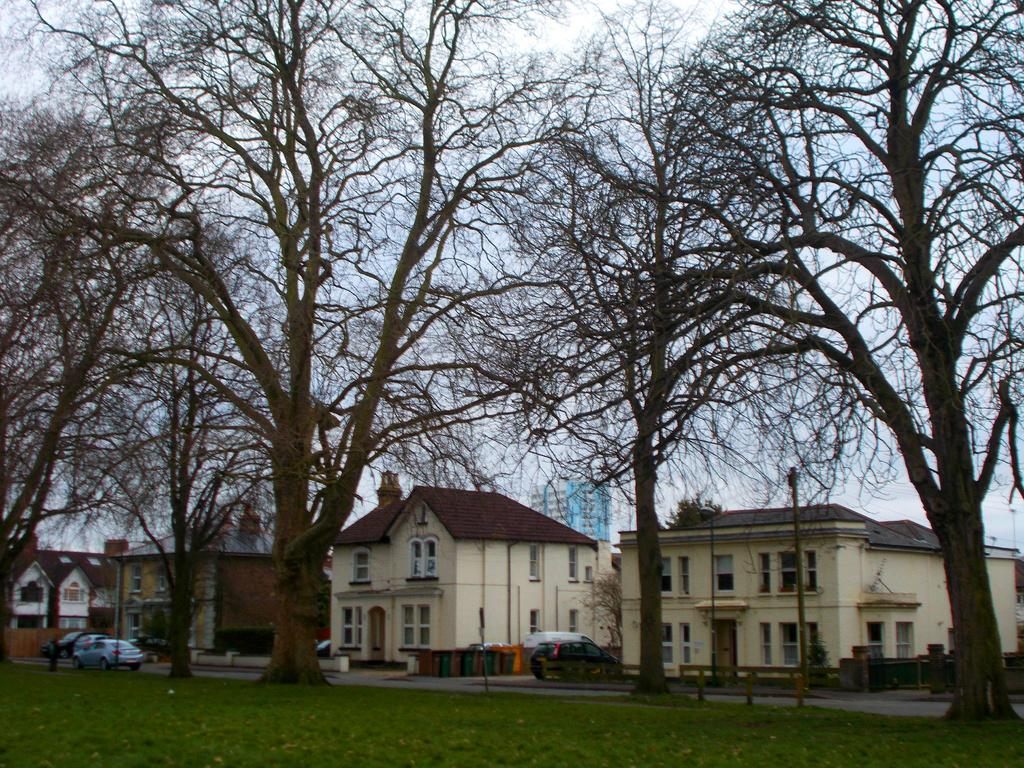What types of structures are located at the bottom of the image? There are buildings at the bottom of the image. What else can be seen at the bottom of the image besides buildings? Vehicles, walls, windows, poles, trees, and a road are visible at the bottom of the image. Additionally, grass is visible at the bottom of the image. What is visible in the background of the image? The sky is visible in the background of the image. How many apples are hanging from the trees at the bottom of the image? There are no apples present in the image; only trees are visible. What type of form does the toe of the person in the image have? There is no person present in the image, so it is not possible to determine the form of their toe. 